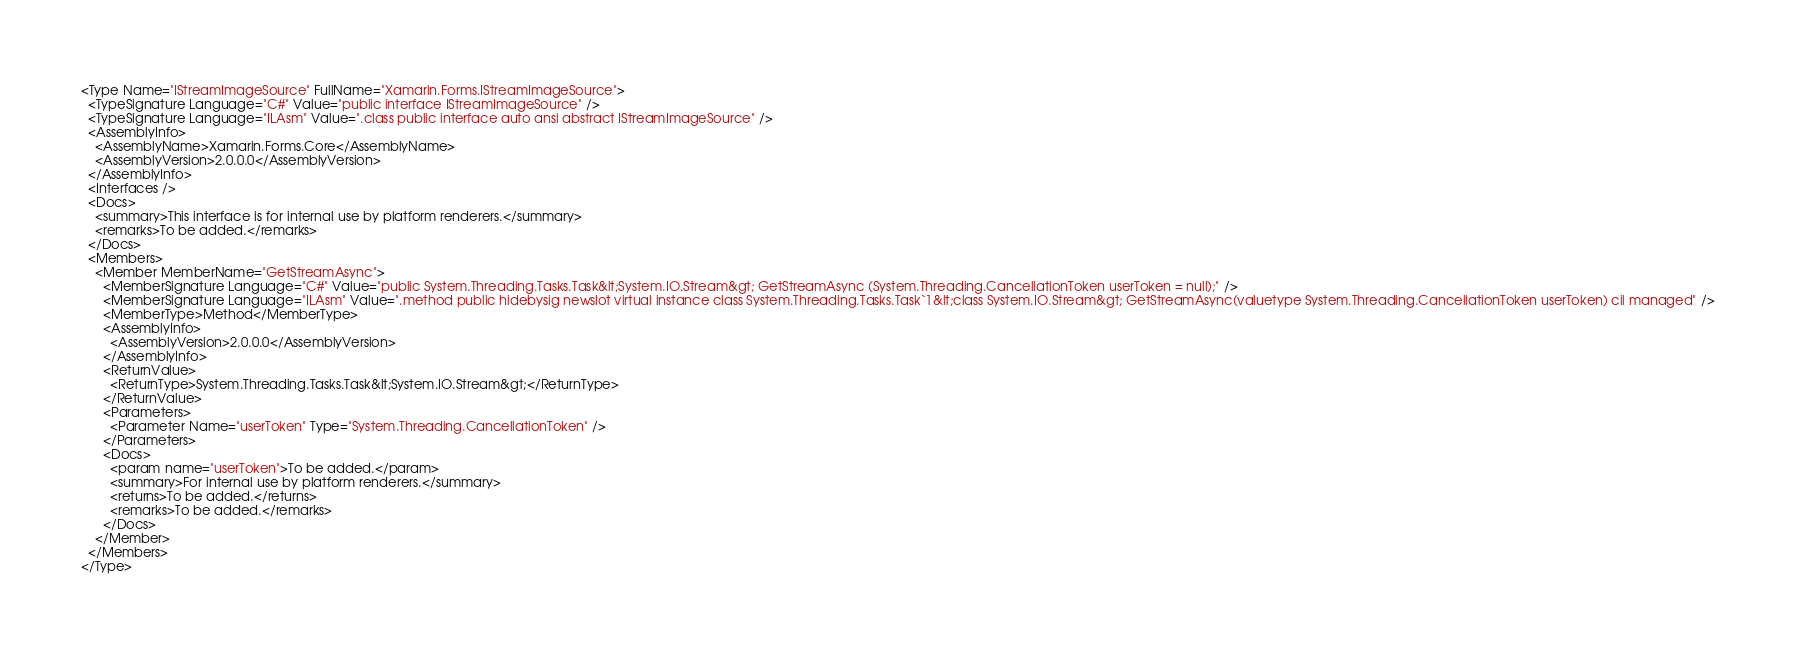Convert code to text. <code><loc_0><loc_0><loc_500><loc_500><_XML_><Type Name="IStreamImageSource" FullName="Xamarin.Forms.IStreamImageSource">
  <TypeSignature Language="C#" Value="public interface IStreamImageSource" />
  <TypeSignature Language="ILAsm" Value=".class public interface auto ansi abstract IStreamImageSource" />
  <AssemblyInfo>
    <AssemblyName>Xamarin.Forms.Core</AssemblyName>
    <AssemblyVersion>2.0.0.0</AssemblyVersion>
  </AssemblyInfo>
  <Interfaces />
  <Docs>
    <summary>This interface is for internal use by platform renderers.</summary>
    <remarks>To be added.</remarks>
  </Docs>
  <Members>
    <Member MemberName="GetStreamAsync">
      <MemberSignature Language="C#" Value="public System.Threading.Tasks.Task&lt;System.IO.Stream&gt; GetStreamAsync (System.Threading.CancellationToken userToken = null);" />
      <MemberSignature Language="ILAsm" Value=".method public hidebysig newslot virtual instance class System.Threading.Tasks.Task`1&lt;class System.IO.Stream&gt; GetStreamAsync(valuetype System.Threading.CancellationToken userToken) cil managed" />
      <MemberType>Method</MemberType>
      <AssemblyInfo>
        <AssemblyVersion>2.0.0.0</AssemblyVersion>
      </AssemblyInfo>
      <ReturnValue>
        <ReturnType>System.Threading.Tasks.Task&lt;System.IO.Stream&gt;</ReturnType>
      </ReturnValue>
      <Parameters>
        <Parameter Name="userToken" Type="System.Threading.CancellationToken" />
      </Parameters>
      <Docs>
        <param name="userToken">To be added.</param>
        <summary>For internal use by platform renderers.</summary>
        <returns>To be added.</returns>
        <remarks>To be added.</remarks>
      </Docs>
    </Member>
  </Members>
</Type>
</code> 